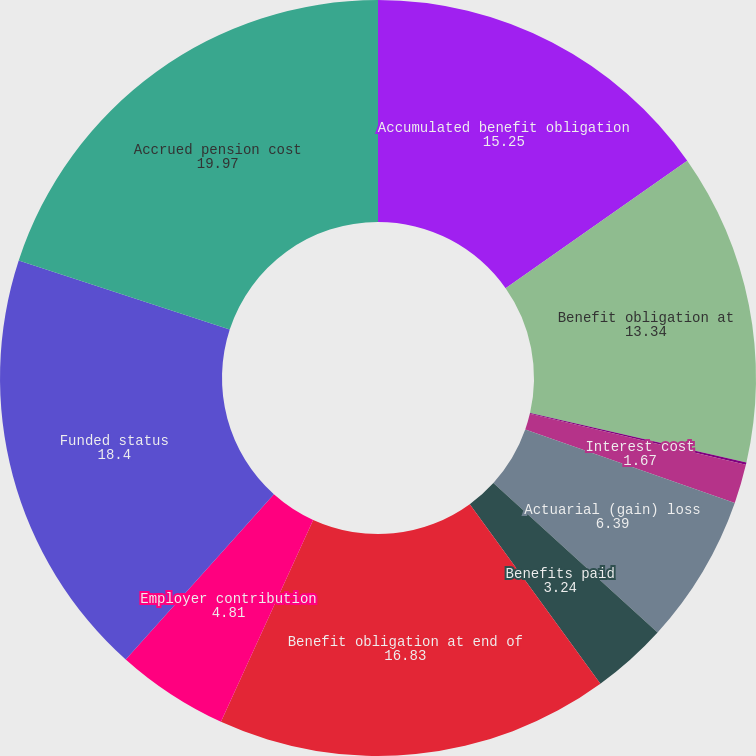Convert chart to OTSL. <chart><loc_0><loc_0><loc_500><loc_500><pie_chart><fcel>Accumulated benefit obligation<fcel>Benefit obligation at<fcel>Service cost<fcel>Interest cost<fcel>Actuarial (gain) loss<fcel>Benefits paid<fcel>Benefit obligation at end of<fcel>Employer contribution<fcel>Funded status<fcel>Accrued pension cost<nl><fcel>15.25%<fcel>13.34%<fcel>0.1%<fcel>1.67%<fcel>6.39%<fcel>3.24%<fcel>16.83%<fcel>4.81%<fcel>18.4%<fcel>19.97%<nl></chart> 